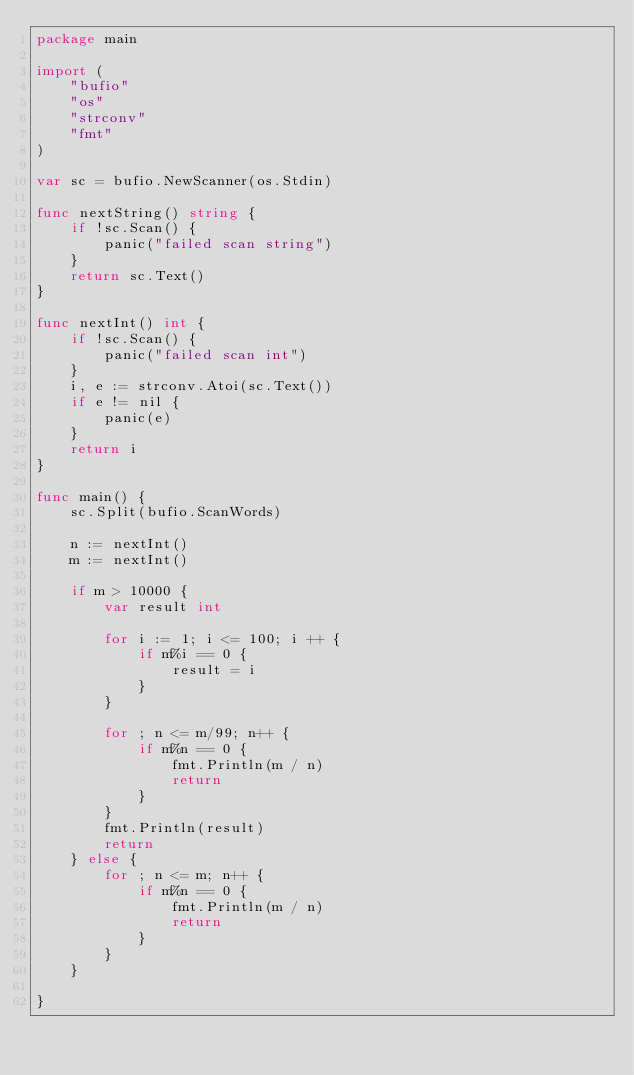<code> <loc_0><loc_0><loc_500><loc_500><_Go_>package main

import (
	"bufio"
	"os"
	"strconv"
	"fmt"
)

var sc = bufio.NewScanner(os.Stdin)

func nextString() string {
	if !sc.Scan() {
		panic("failed scan string")
	}
	return sc.Text()
}

func nextInt() int {
	if !sc.Scan() {
		panic("failed scan int")
	}
	i, e := strconv.Atoi(sc.Text())
	if e != nil {
		panic(e)
	}
	return i
}

func main() {
	sc.Split(bufio.ScanWords)

	n := nextInt()
	m := nextInt()

	if m > 10000 {
		var result int

		for i := 1; i <= 100; i ++ {
			if m%i == 0 {
				result = i
			}
		}

		for ; n <= m/99; n++ {
			if m%n == 0 {
				fmt.Println(m / n)
				return
			}
		}
		fmt.Println(result)
		return
	} else {
		for ; n <= m; n++ {
			if m%n == 0 {
				fmt.Println(m / n)
				return
			}
		}
	}

}
</code> 